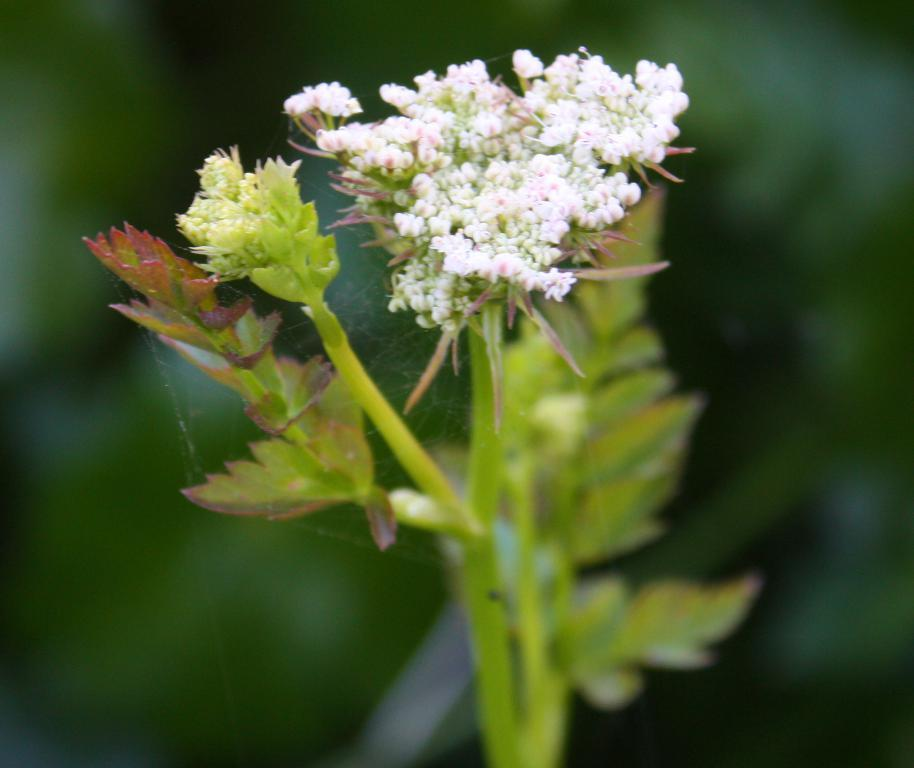What type of plants are in the image? There are plants with flowers in the image. How is the background of the image depicted? The background of the image is blurred. Can you describe any objects visible in the background? There are objects visible in the background of the image, but their specific details are not clear due to the blurred background. What type of potato is being used to generate new ideas in the image? There is no potato or idea generation process depicted in the image; it features plants with flowers and a blurred background. 